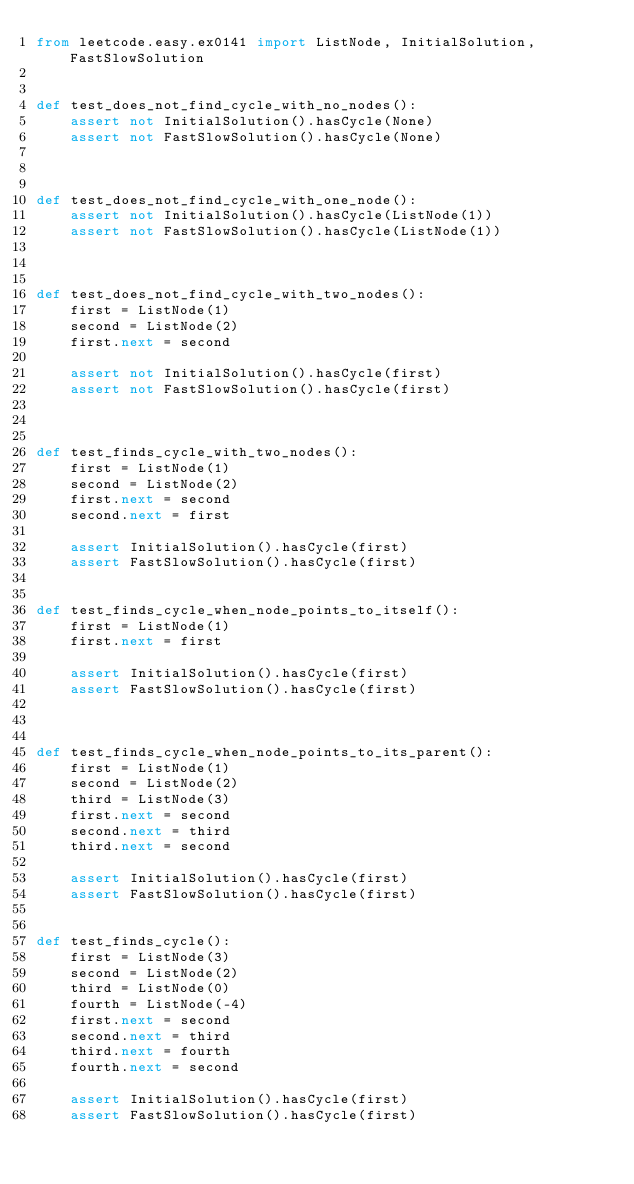Convert code to text. <code><loc_0><loc_0><loc_500><loc_500><_Python_>from leetcode.easy.ex0141 import ListNode, InitialSolution, FastSlowSolution


def test_does_not_find_cycle_with_no_nodes():
    assert not InitialSolution().hasCycle(None)
    assert not FastSlowSolution().hasCycle(None)



def test_does_not_find_cycle_with_one_node():
    assert not InitialSolution().hasCycle(ListNode(1))
    assert not FastSlowSolution().hasCycle(ListNode(1))



def test_does_not_find_cycle_with_two_nodes():
    first = ListNode(1)
    second = ListNode(2)
    first.next = second

    assert not InitialSolution().hasCycle(first)
    assert not FastSlowSolution().hasCycle(first)



def test_finds_cycle_with_two_nodes():
    first = ListNode(1)
    second = ListNode(2)
    first.next = second
    second.next = first

    assert InitialSolution().hasCycle(first)
    assert FastSlowSolution().hasCycle(first)


def test_finds_cycle_when_node_points_to_itself():
    first = ListNode(1)
    first.next = first

    assert InitialSolution().hasCycle(first)
    assert FastSlowSolution().hasCycle(first)



def test_finds_cycle_when_node_points_to_its_parent():
    first = ListNode(1)
    second = ListNode(2)
    third = ListNode(3)
    first.next = second
    second.next = third
    third.next = second

    assert InitialSolution().hasCycle(first)
    assert FastSlowSolution().hasCycle(first)


def test_finds_cycle():
    first = ListNode(3)
    second = ListNode(2)
    third = ListNode(0)
    fourth = ListNode(-4)
    first.next = second
    second.next = third
    third.next = fourth
    fourth.next = second

    assert InitialSolution().hasCycle(first)
    assert FastSlowSolution().hasCycle(first)
</code> 